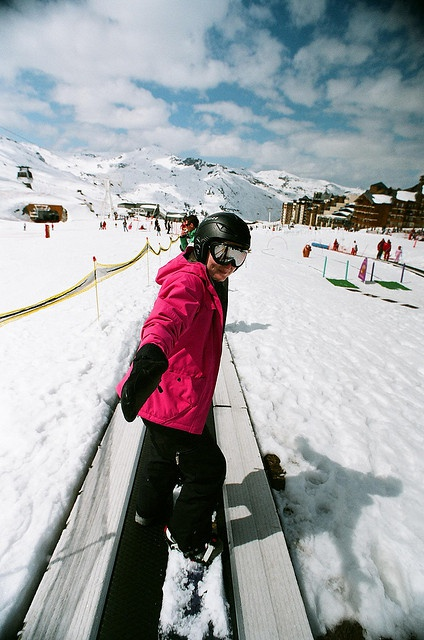Describe the objects in this image and their specific colors. I can see people in black, maroon, and brown tones, snowboard in black, lightgray, darkgray, and gray tones, people in black, darkgreen, and maroon tones, people in black, maroon, and gray tones, and people in black, maroon, and gray tones in this image. 